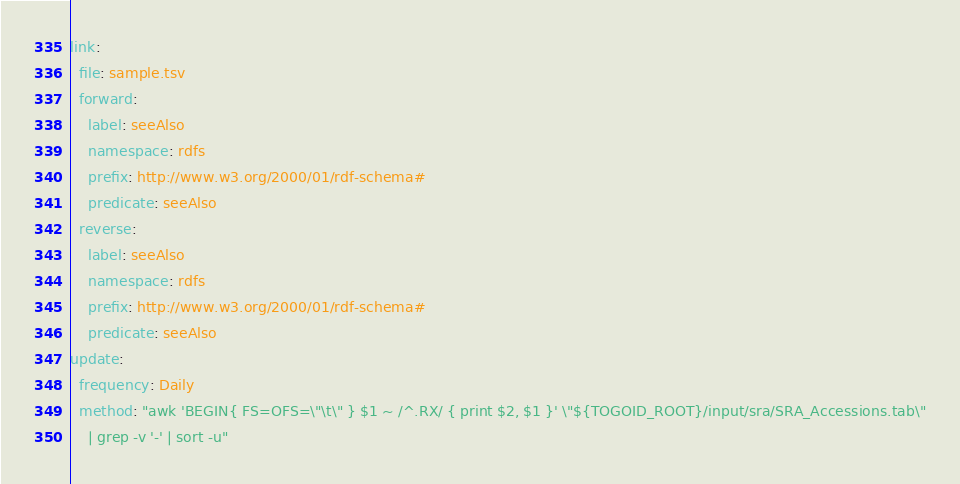<code> <loc_0><loc_0><loc_500><loc_500><_YAML_>link:
  file: sample.tsv
  forward:
    label: seeAlso
    namespace: rdfs
    prefix: http://www.w3.org/2000/01/rdf-schema#
    predicate: seeAlso
  reverse:
    label: seeAlso
    namespace: rdfs
    prefix: http://www.w3.org/2000/01/rdf-schema#
    predicate: seeAlso
update:
  frequency: Daily
  method: "awk 'BEGIN{ FS=OFS=\"\t\" } $1 ~ /^.RX/ { print $2, $1 }' \"${TOGOID_ROOT}/input/sra/SRA_Accessions.tab\"
    | grep -v '-' | sort -u"
</code> 